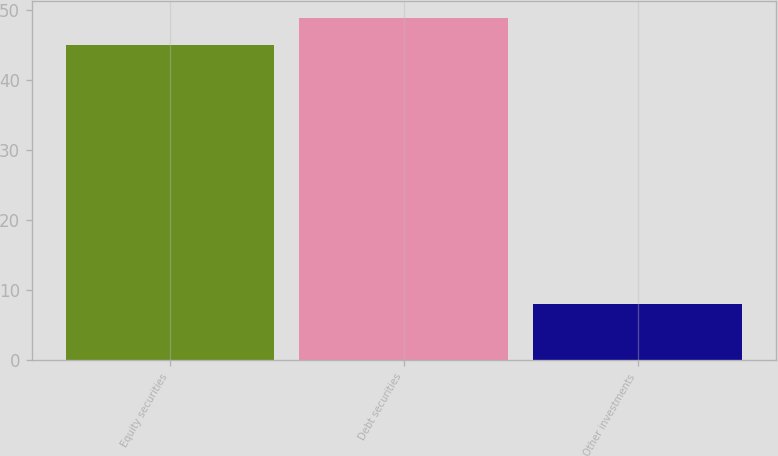Convert chart. <chart><loc_0><loc_0><loc_500><loc_500><bar_chart><fcel>Equity securities<fcel>Debt securities<fcel>Other investments<nl><fcel>45<fcel>48.9<fcel>8<nl></chart> 